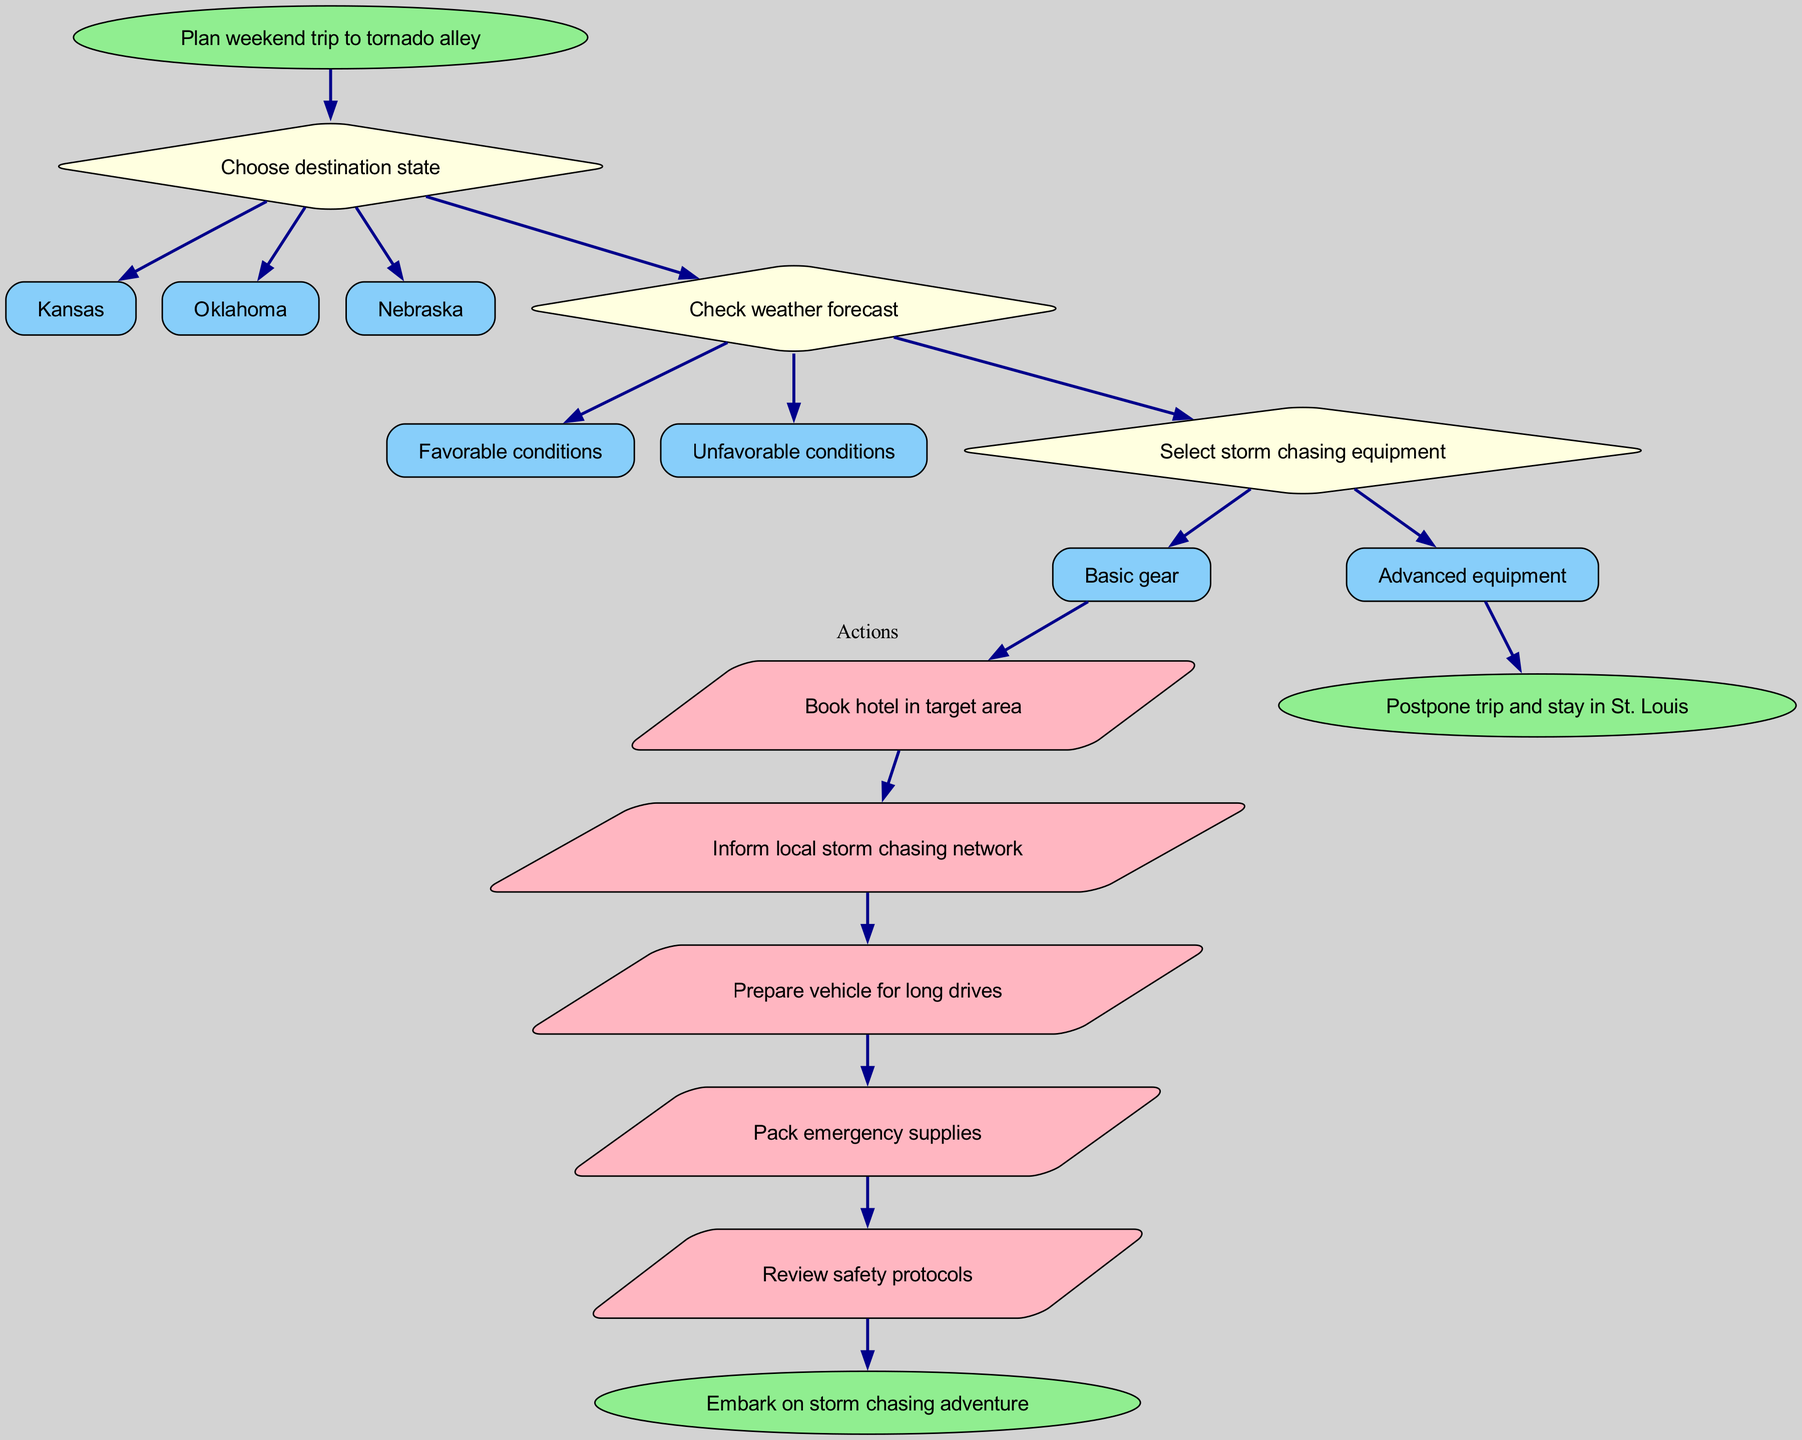What is the starting point in the flow chart? The flow chart begins with the node labeled "Plan weekend trip to tornado alley." This is the first action that directs the decision-making process towards planning the trip.
Answer: Plan weekend trip to tornado alley How many destination states can be chosen? In the diagram, there are three options listed under the decision regarding the destination state: Kansas, Oklahoma, and Nebraska. Thus, the number of destination states that can be chosen is three.
Answer: 3 What are the first actions to take if unfavorable weather conditions arise? If the weather conditions are unfavorable, the flow chart directs to a node leading to the action "Postpone trip and stay in St. Louis." Therefore, the first action is to postpone the trip.
Answer: Postpone trip and stay in St. Louis Which action follows the last decision node? The last decision node is "Check weather forecast," and if favorable conditions are indicated, the next action is "Book hotel in target area." This means that the next action directly following the last decision node is to book a hotel.
Answer: Book hotel in target area What type of node represents the actions in the flow chart? The actions within the flow chart are represented by parallelogram-shaped nodes. This is distinct as it indicates a process or action to take place.
Answer: Parallelogram If Nebraska is chosen as the destination, what would be the next step regarding the weather? Regardless of the chosen destination, after selecting Nebraska, the next step remains checking the weather conditions. After this decision, the flow would proceed based on whether the conditions are favorable or unfavorable.
Answer: Check weather forecast How many action nodes are present after making decisions? The diagram indicates five actions following the decision nodes, suggesting a structured pathway of actions that can be taken after determining the weather conditions.
Answer: 5 What is the end result if the trip is not postponed? If the trip is not postponed due to unfavorable conditions, the flow chart indicates the end result is to "Embark on storm chasing adventure." Thus, this summarizes the conclusion of the diagram's intended flow.
Answer: Embark on storm chasing adventure 